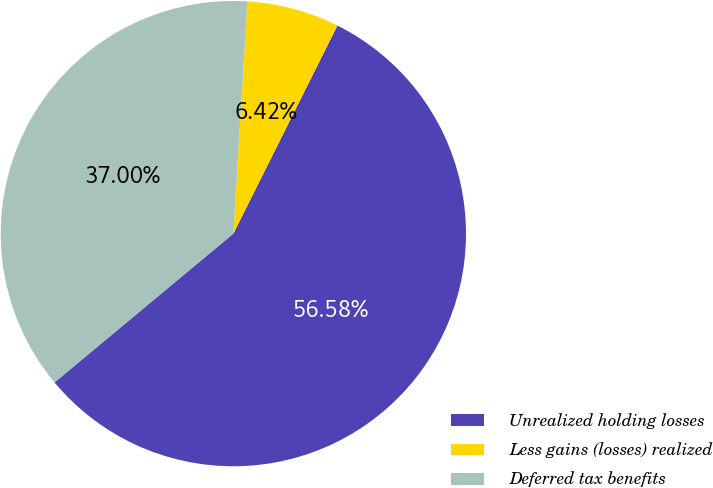Convert chart. <chart><loc_0><loc_0><loc_500><loc_500><pie_chart><fcel>Unrealized holding losses<fcel>Less gains (losses) realized<fcel>Deferred tax benefits<nl><fcel>56.57%<fcel>6.42%<fcel>37.0%<nl></chart> 